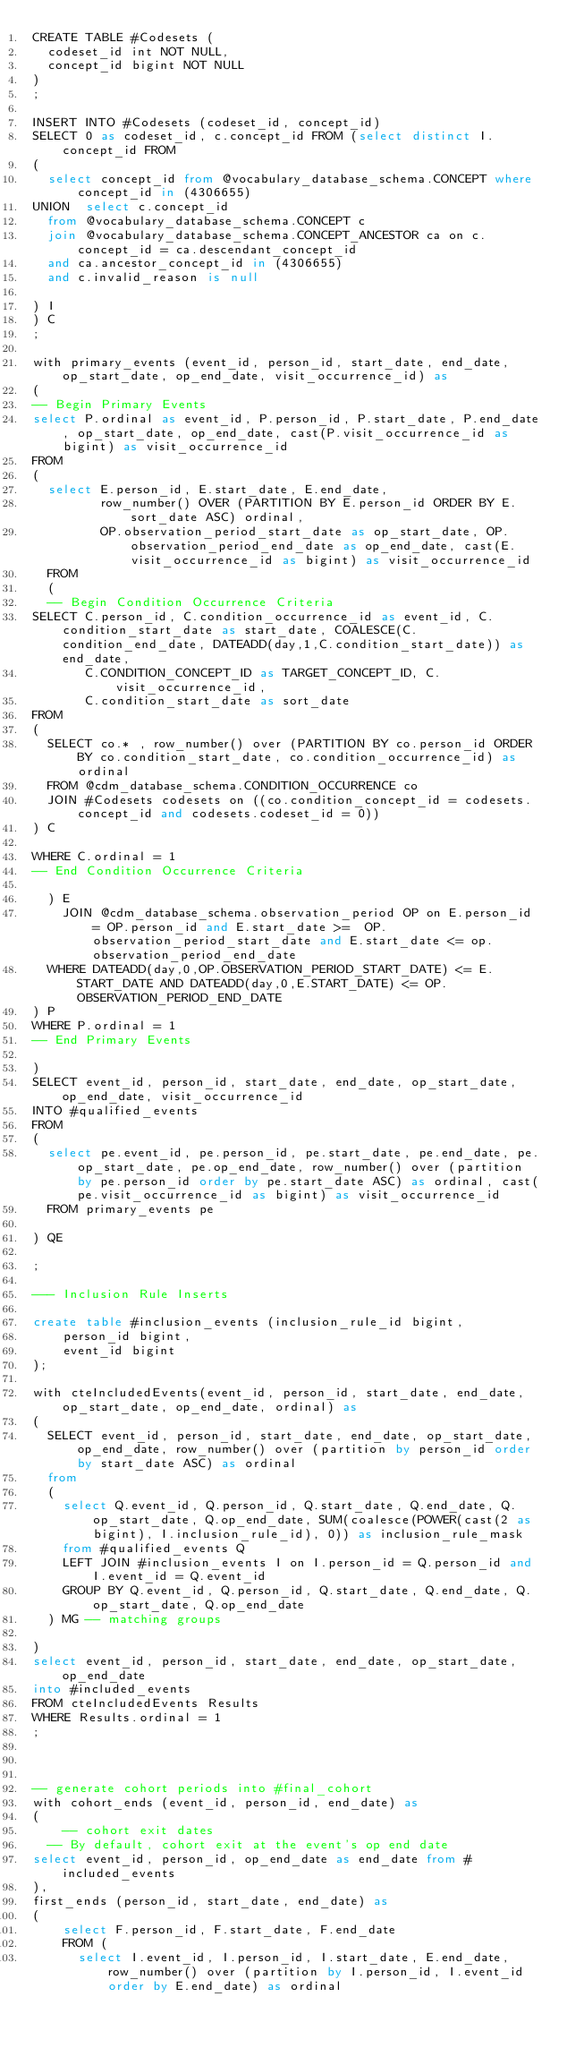Convert code to text. <code><loc_0><loc_0><loc_500><loc_500><_SQL_>CREATE TABLE #Codesets (
  codeset_id int NOT NULL,
  concept_id bigint NOT NULL
)
;

INSERT INTO #Codesets (codeset_id, concept_id)
SELECT 0 as codeset_id, c.concept_id FROM (select distinct I.concept_id FROM
( 
  select concept_id from @vocabulary_database_schema.CONCEPT where concept_id in (4306655)
UNION  select c.concept_id
  from @vocabulary_database_schema.CONCEPT c
  join @vocabulary_database_schema.CONCEPT_ANCESTOR ca on c.concept_id = ca.descendant_concept_id
  and ca.ancestor_concept_id in (4306655)
  and c.invalid_reason is null

) I
) C
;

with primary_events (event_id, person_id, start_date, end_date, op_start_date, op_end_date, visit_occurrence_id) as
(
-- Begin Primary Events
select P.ordinal as event_id, P.person_id, P.start_date, P.end_date, op_start_date, op_end_date, cast(P.visit_occurrence_id as bigint) as visit_occurrence_id
FROM
(
  select E.person_id, E.start_date, E.end_date,
         row_number() OVER (PARTITION BY E.person_id ORDER BY E.sort_date ASC) ordinal,
         OP.observation_period_start_date as op_start_date, OP.observation_period_end_date as op_end_date, cast(E.visit_occurrence_id as bigint) as visit_occurrence_id
  FROM 
  (
  -- Begin Condition Occurrence Criteria
SELECT C.person_id, C.condition_occurrence_id as event_id, C.condition_start_date as start_date, COALESCE(C.condition_end_date, DATEADD(day,1,C.condition_start_date)) as end_date,
       C.CONDITION_CONCEPT_ID as TARGET_CONCEPT_ID, C.visit_occurrence_id,
       C.condition_start_date as sort_date
FROM 
(
  SELECT co.* , row_number() over (PARTITION BY co.person_id ORDER BY co.condition_start_date, co.condition_occurrence_id) as ordinal
  FROM @cdm_database_schema.CONDITION_OCCURRENCE co
  JOIN #Codesets codesets on ((co.condition_concept_id = codesets.concept_id and codesets.codeset_id = 0))
) C

WHERE C.ordinal = 1
-- End Condition Occurrence Criteria

  ) E
	JOIN @cdm_database_schema.observation_period OP on E.person_id = OP.person_id and E.start_date >=  OP.observation_period_start_date and E.start_date <= op.observation_period_end_date
  WHERE DATEADD(day,0,OP.OBSERVATION_PERIOD_START_DATE) <= E.START_DATE AND DATEADD(day,0,E.START_DATE) <= OP.OBSERVATION_PERIOD_END_DATE
) P
WHERE P.ordinal = 1
-- End Primary Events

)
SELECT event_id, person_id, start_date, end_date, op_start_date, op_end_date, visit_occurrence_id
INTO #qualified_events
FROM 
(
  select pe.event_id, pe.person_id, pe.start_date, pe.end_date, pe.op_start_date, pe.op_end_date, row_number() over (partition by pe.person_id order by pe.start_date ASC) as ordinal, cast(pe.visit_occurrence_id as bigint) as visit_occurrence_id
  FROM primary_events pe
  
) QE

;

--- Inclusion Rule Inserts

create table #inclusion_events (inclusion_rule_id bigint,
	person_id bigint,
	event_id bigint
);

with cteIncludedEvents(event_id, person_id, start_date, end_date, op_start_date, op_end_date, ordinal) as
(
  SELECT event_id, person_id, start_date, end_date, op_start_date, op_end_date, row_number() over (partition by person_id order by start_date ASC) as ordinal
  from
  (
    select Q.event_id, Q.person_id, Q.start_date, Q.end_date, Q.op_start_date, Q.op_end_date, SUM(coalesce(POWER(cast(2 as bigint), I.inclusion_rule_id), 0)) as inclusion_rule_mask
    from #qualified_events Q
    LEFT JOIN #inclusion_events I on I.person_id = Q.person_id and I.event_id = Q.event_id
    GROUP BY Q.event_id, Q.person_id, Q.start_date, Q.end_date, Q.op_start_date, Q.op_end_date
  ) MG -- matching groups

)
select event_id, person_id, start_date, end_date, op_start_date, op_end_date
into #included_events
FROM cteIncludedEvents Results
WHERE Results.ordinal = 1
;



-- generate cohort periods into #final_cohort
with cohort_ends (event_id, person_id, end_date) as
(
	-- cohort exit dates
  -- By default, cohort exit at the event's op end date
select event_id, person_id, op_end_date as end_date from #included_events
),
first_ends (person_id, start_date, end_date) as
(
	select F.person_id, F.start_date, F.end_date
	FROM (
	  select I.event_id, I.person_id, I.start_date, E.end_date, row_number() over (partition by I.person_id, I.event_id order by E.end_date) as ordinal </code> 